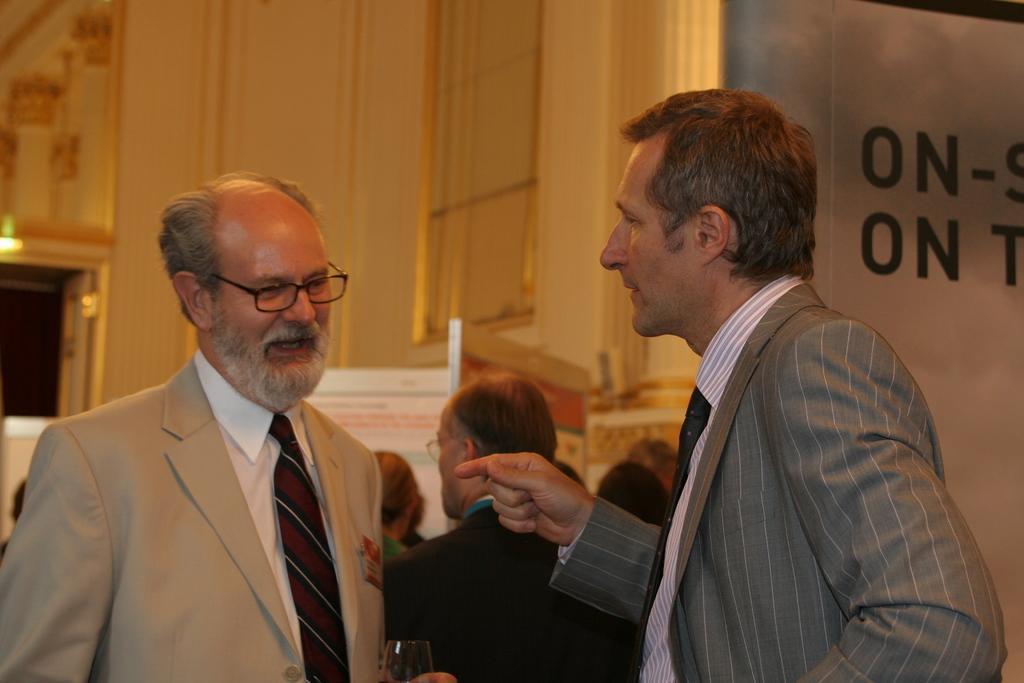Describe this image in one or two sentences. In this image we can see some people standing. In that a man is holding a glass. On the backside we can see a wall and some boards with text on them. 